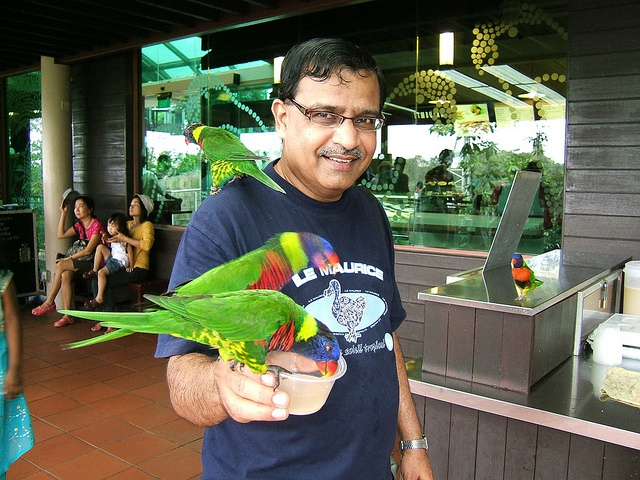Describe the objects in this image and their specific colors. I can see people in black, ivory, and darkblue tones, bird in black, green, and lightgreen tones, bird in black, green, lime, and lightgreen tones, people in black, teal, and maroon tones, and people in black, maroon, gray, and brown tones in this image. 